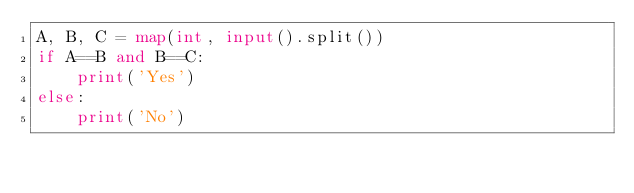<code> <loc_0><loc_0><loc_500><loc_500><_Python_>A, B, C = map(int, input().split())
if A==B and B==C:
    print('Yes')
else:
    print('No')</code> 